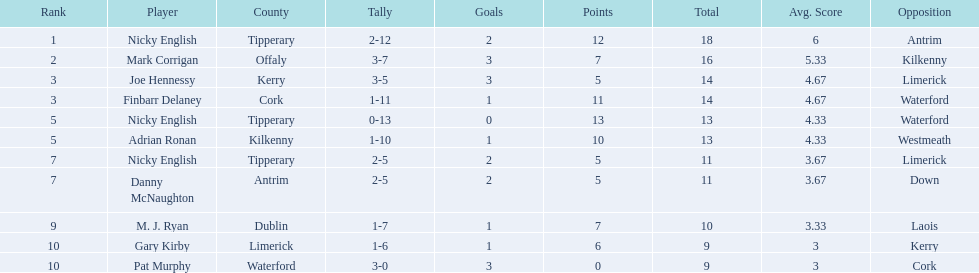What was the combined total of nicky english and mark corrigan? 34. Write the full table. {'header': ['Rank', 'Player', 'County', 'Tally', 'Goals', 'Points', 'Total', 'Avg. Score', 'Opposition'], 'rows': [['1', 'Nicky English', 'Tipperary', '2-12', '2', '12', '18', '6', 'Antrim'], ['2', 'Mark Corrigan', 'Offaly', '3-7', '3', '7', '16', '5.33', 'Kilkenny'], ['3', 'Joe Hennessy', 'Kerry', '3-5', '3', '5', '14', '4.67', 'Limerick'], ['3', 'Finbarr Delaney', 'Cork', '1-11', '1', '11', '14', '4.67', 'Waterford'], ['5', 'Nicky English', 'Tipperary', '0-13', '0', '13', '13', '4.33', 'Waterford'], ['5', 'Adrian Ronan', 'Kilkenny', '1-10', '1', '10', '13', '4.33', 'Westmeath'], ['7', 'Nicky English', 'Tipperary', '2-5', '2', '5', '11', '3.67', 'Limerick'], ['7', 'Danny McNaughton', 'Antrim', '2-5', '2', '5', '11', '3.67', 'Down'], ['9', 'M. J. Ryan', 'Dublin', '1-7', '1', '7', '10', '3.33', 'Laois'], ['10', 'Gary Kirby', 'Limerick', '1-6', '1', '6', '9', '3', 'Kerry'], ['10', 'Pat Murphy', 'Waterford', '3-0', '3', '0', '9', '3', 'Cork']]} 